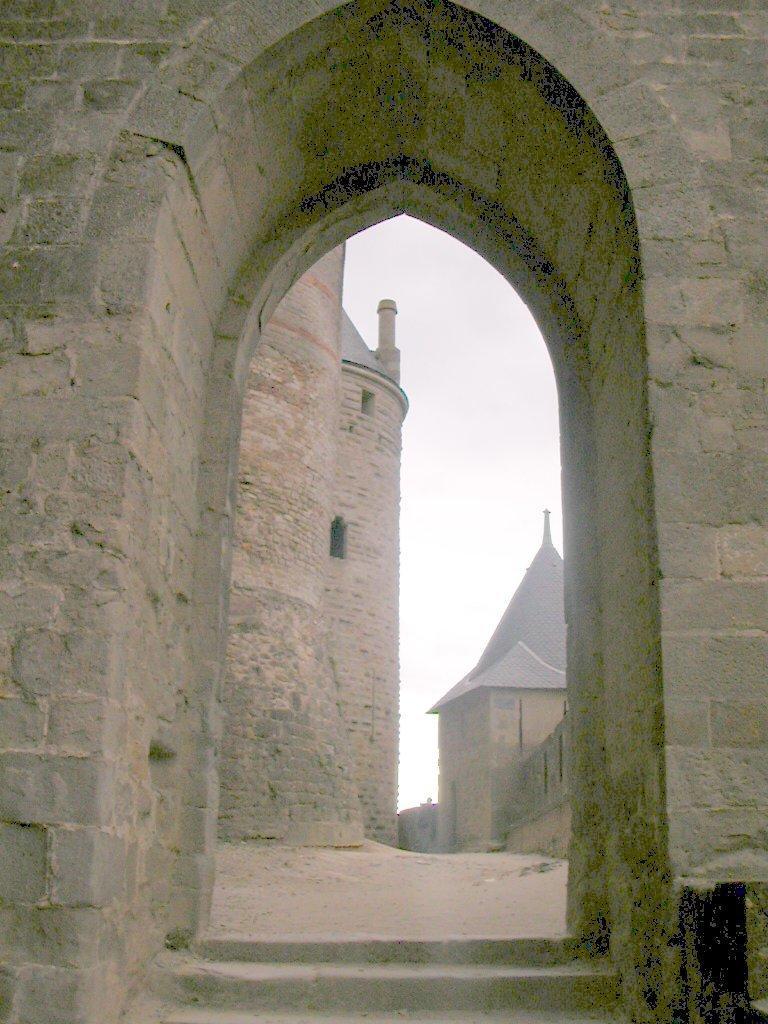Can you describe this image briefly? In this image, we can see there is an arch. Through this arch, we can see there are buildings on the ground. And there are clouds in the sky. 